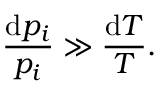Convert formula to latex. <formula><loc_0><loc_0><loc_500><loc_500>\frac { d p _ { i } } { p _ { i } } \gg \frac { d T } { T } .</formula> 